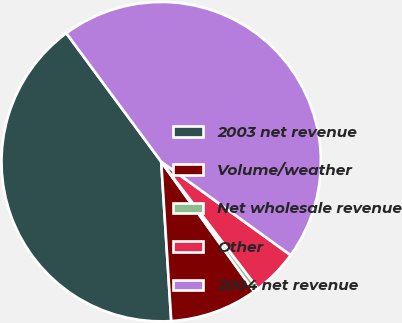<chart> <loc_0><loc_0><loc_500><loc_500><pie_chart><fcel>2003 net revenue<fcel>Volume/weather<fcel>Net wholesale revenue<fcel>Other<fcel>2004 net revenue<nl><fcel>40.88%<fcel>8.88%<fcel>0.48%<fcel>4.68%<fcel>45.08%<nl></chart> 